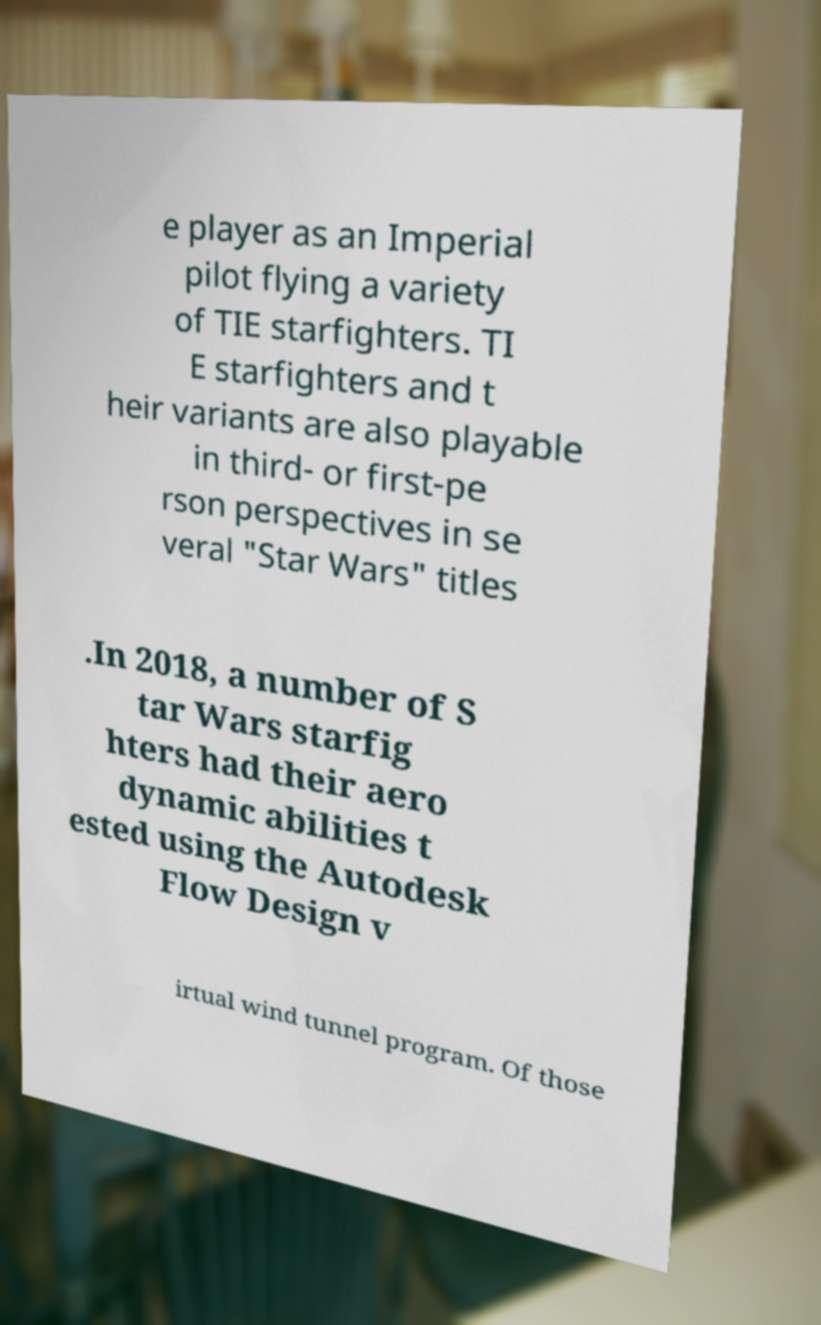Can you read and provide the text displayed in the image?This photo seems to have some interesting text. Can you extract and type it out for me? e player as an Imperial pilot flying a variety of TIE starfighters. TI E starfighters and t heir variants are also playable in third- or first-pe rson perspectives in se veral "Star Wars" titles .In 2018, a number of S tar Wars starfig hters had their aero dynamic abilities t ested using the Autodesk Flow Design v irtual wind tunnel program. Of those 